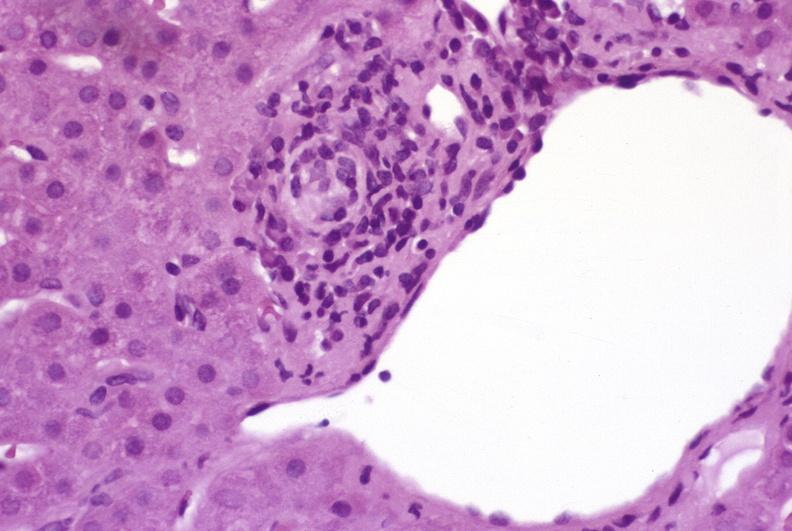does foot show mild-to-moderate acute rejection?
Answer the question using a single word or phrase. No 